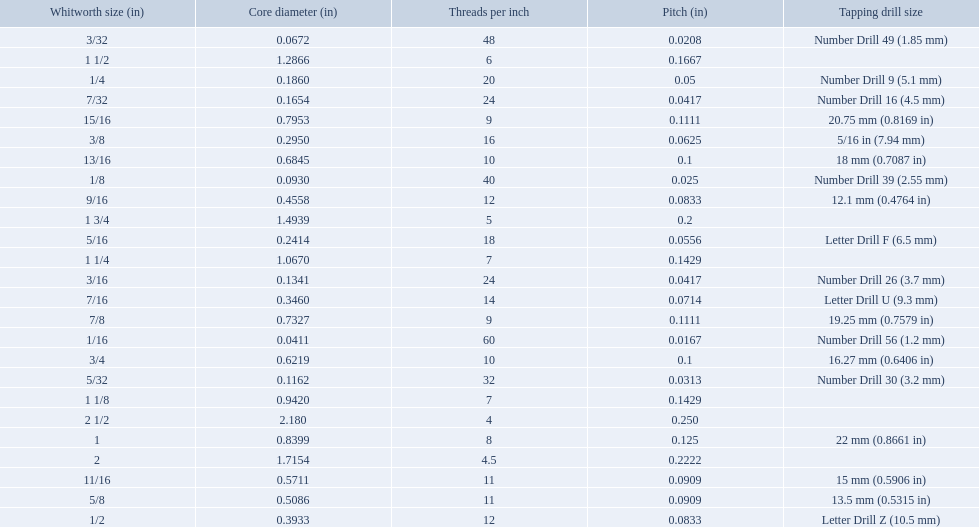What is the core diameter for the number drill 26? 0.1341. What is the whitworth size (in) for this core diameter? 3/16. What are the sizes of threads per inch? 60, 48, 40, 32, 24, 24, 20, 18, 16, 14, 12, 12, 11, 11, 10, 10, 9, 9, 8, 7, 7, 6, 5, 4.5, 4. Which whitworth size has only 5 threads per inch? 1 3/4. What are all the whitworth sizes? 1/16, 3/32, 1/8, 5/32, 3/16, 7/32, 1/4, 5/16, 3/8, 7/16, 1/2, 9/16, 5/8, 11/16, 3/4, 13/16, 7/8, 15/16, 1, 1 1/8, 1 1/4, 1 1/2, 1 3/4, 2, 2 1/2. What are the threads per inch of these sizes? 60, 48, 40, 32, 24, 24, 20, 18, 16, 14, 12, 12, 11, 11, 10, 10, 9, 9, 8, 7, 7, 6, 5, 4.5, 4. Of these, which are 5? 5. What whitworth size has this threads per inch? 1 3/4. 